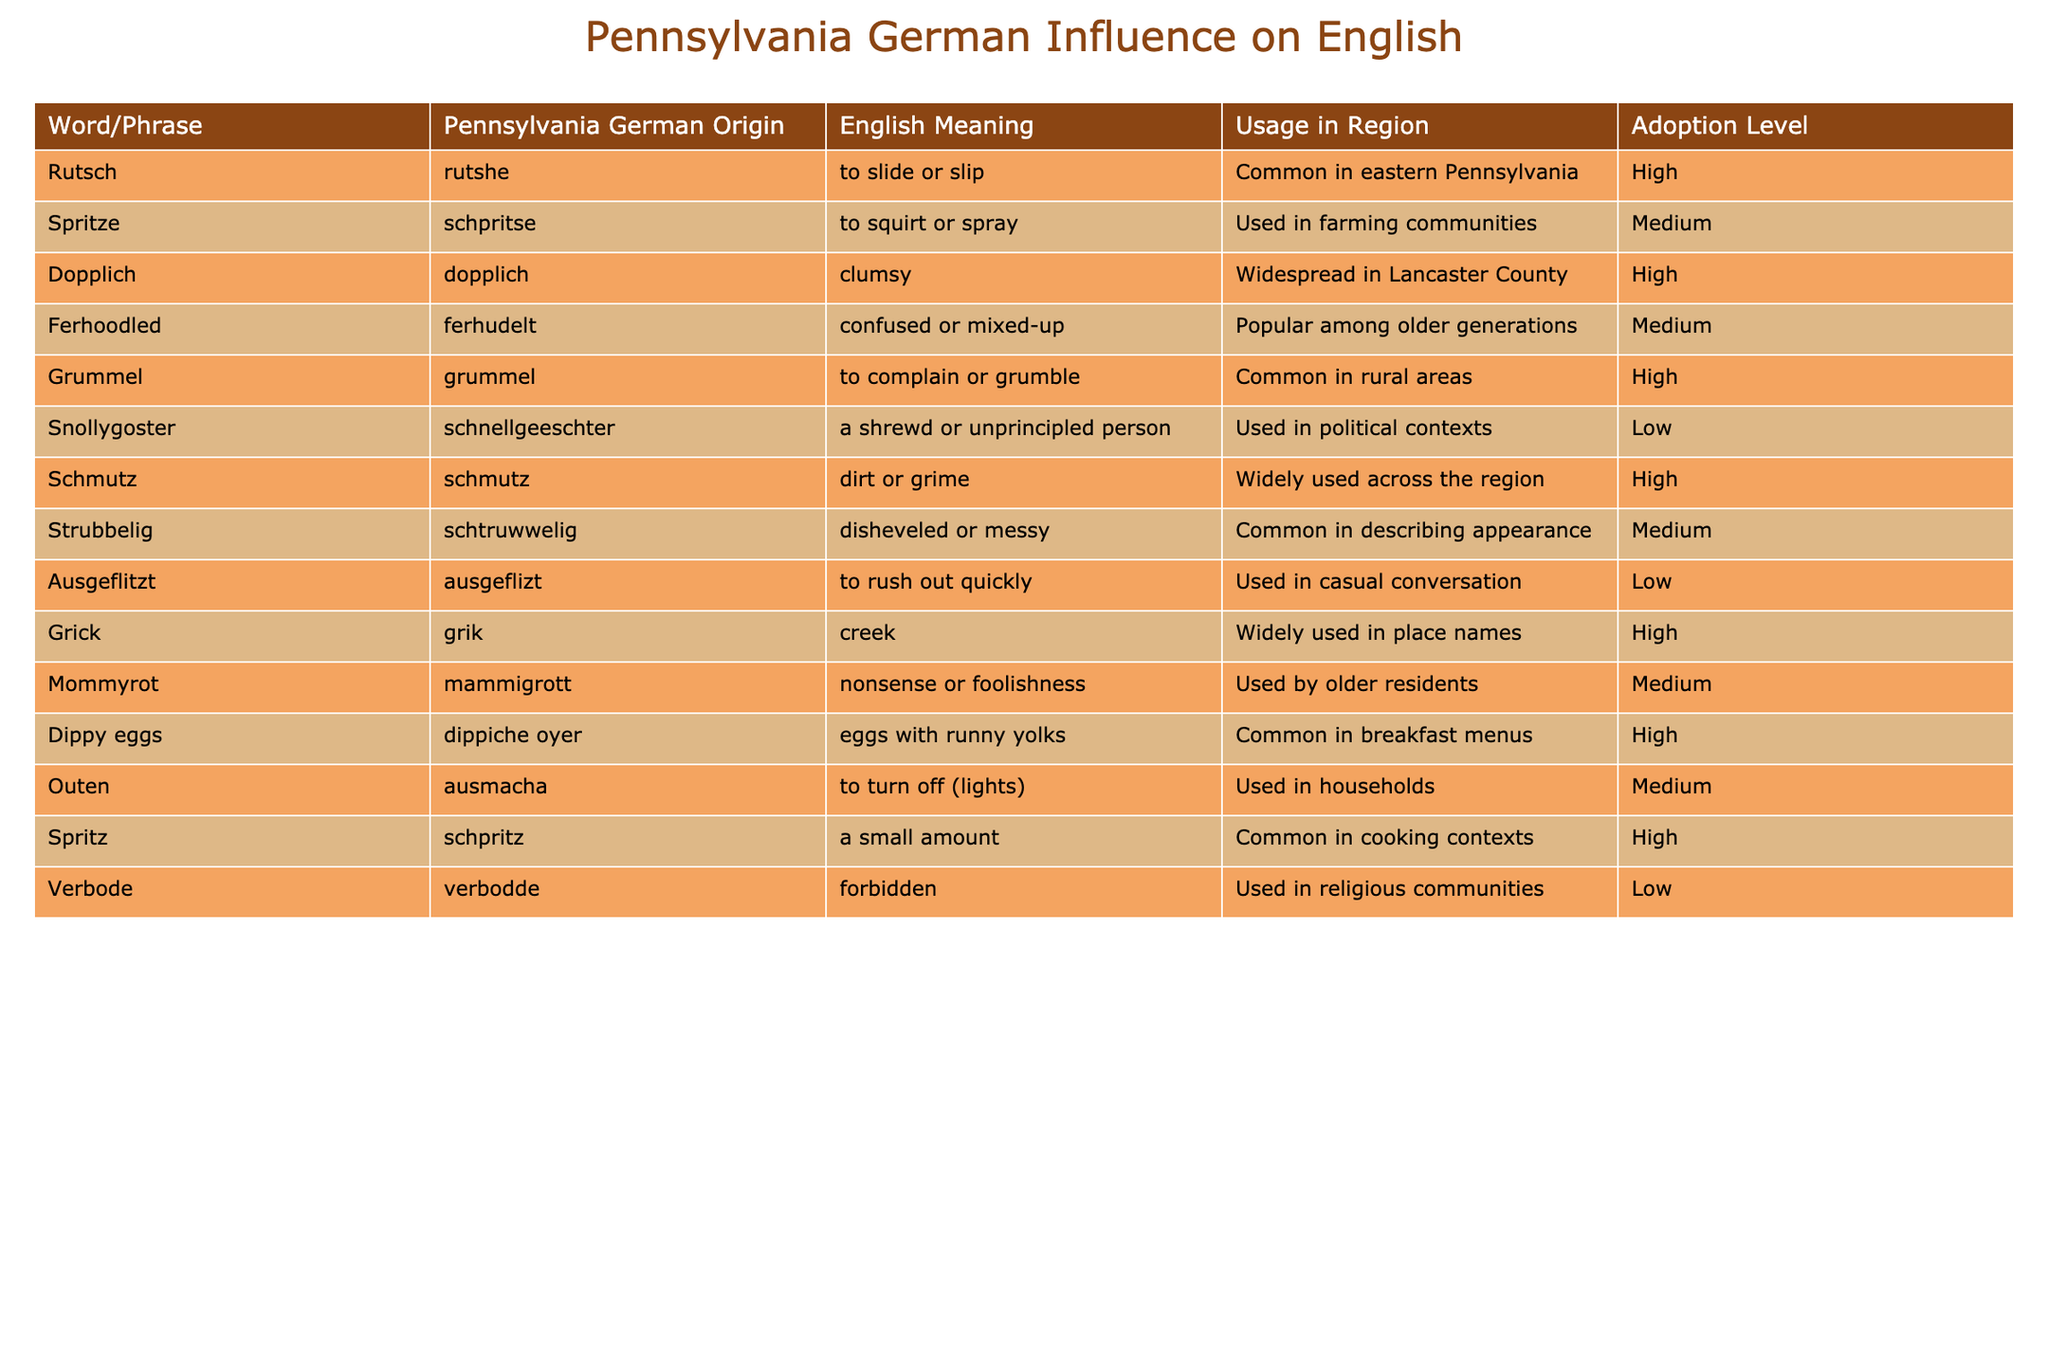What is the Pennsylvania German origin of the word "Rutsch"? The table lists "Rutsch" under the "Word/Phrase" column, and its corresponding Pennsylvania German origin is indicated as "rutshe."
Answer: rutshe Which word or phrase has the highest adoption level in the region? By examining the "Adoption Level" column, "Rutsch," "Dopplich," "Grummel," "Schmutz," "Dippy eggs," and "Spritz" all have a high adoption level. "Rutsch" is listed first according to the table, but each of these words claims high adoption.
Answer: Rutsch, Dopplich, Grummel, Schmutz, Dippy eggs, Spritz How many words or phrases are used in political contexts? The table shows "Snollygoster" listed under "Usage in Region" with the description of its use in political contexts. This is the only phrase dedicated to that category.
Answer: 1 Is "Ausgeflitzt" commonly used in the region? In the "Usage in Region" column, "Ausgeflitzt" is noted as being used in casual conversation, which implies it is not common.
Answer: No What is the average adoption level of words or phrases that have "Medium" listed under adoption level? To determine the average, we identify the phrases with "Medium" adoption level: "Spritze," "Ferhoodled," "Strubbelig," "Mommyrot," "Outen," and "Ausgeflitzt." Their adoption levels can be assigned values: High (3), Medium (2), Low (1). Therefore, (2 + 2 + 2 + 2 + 2 + 1) = 11, and there are 6 phrases. The average adoption level is 11/6, resulting in approximately 1.83, which we can round to 2.
Answer: 2 Which Pennsylvania German word refers to "dirt or grime"? The word that stands for "dirt or grime" in the table is "Schmutz," and it is indicated alongside its Pennsylvania German origin.
Answer: Schmutz Identify a word that is associated with the older generations. The phrases related to older generations in the table include "Ferhoodled" and "Mommyrot," as noted in the "Usage in Region" column.
Answer: Ferhoodled, Mommyrot What are the meanings of the phrases "Dippiche oyer" and "dippiche oyer"? According to the table, "Dippiche oyer" is the Pennsylvania German term, and it translates to "eggs with runny yolks," indicating its common use in breakfast menus.
Answer: eggs with runny yolks Is the term "Snollygoster" widely adopted in the region? The table indicates that "Snollygoster" has a "Low" adoption level, meaning it is not widely used.
Answer: No What is the main theme of the usage of Pennsylvania German words in the table? The table highlights various Pennsylvania German words and phrases with English meanings, corresponding origins, their adoption levels, and contextual usage, showing the influence and integration of Pennsylvania German in regional English.
Answer: Influence of Pennsylvania German on English 